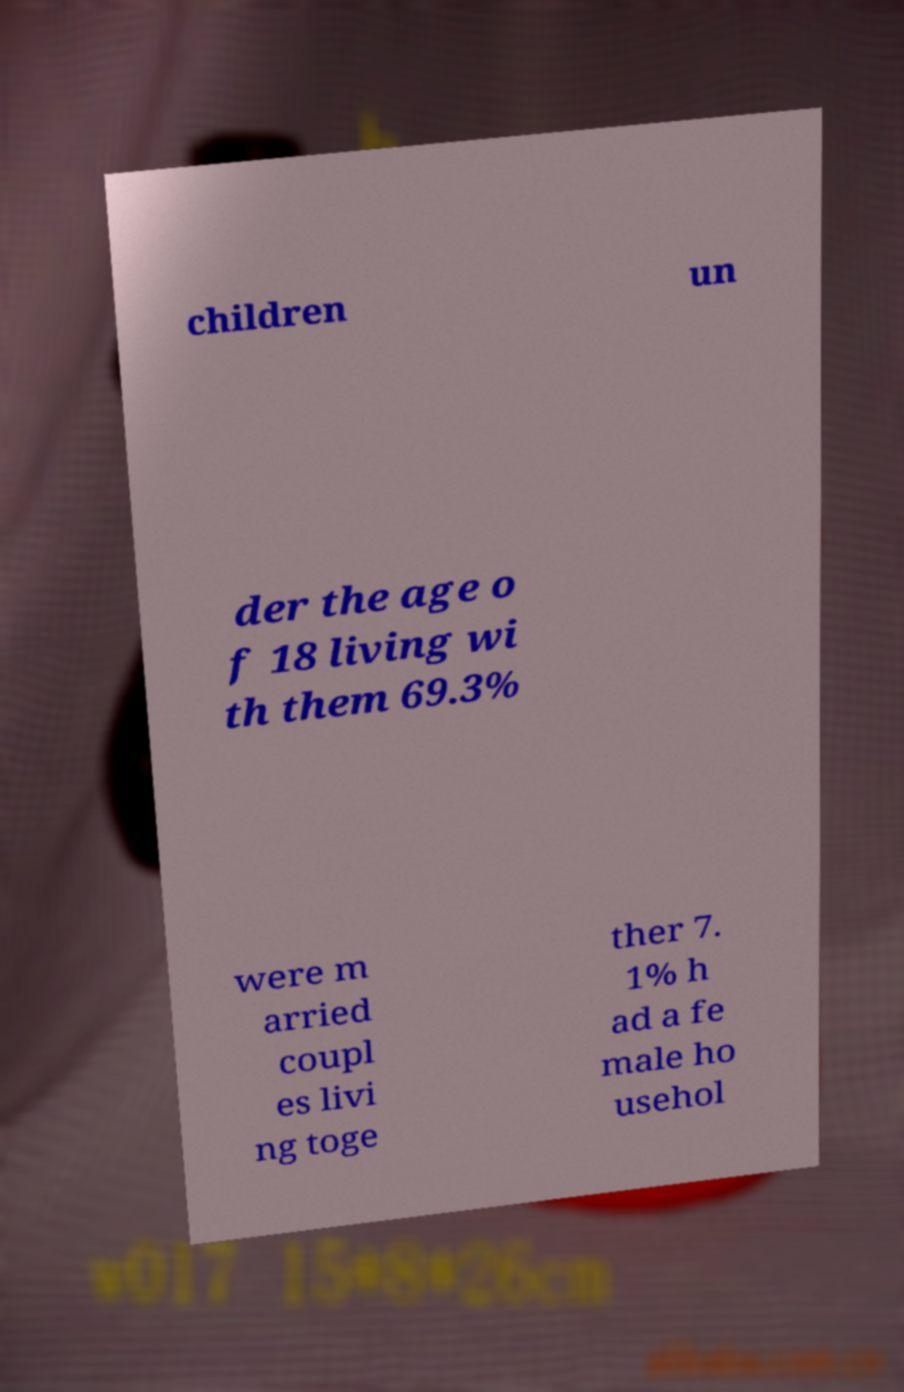Could you extract and type out the text from this image? children un der the age o f 18 living wi th them 69.3% were m arried coupl es livi ng toge ther 7. 1% h ad a fe male ho usehol 